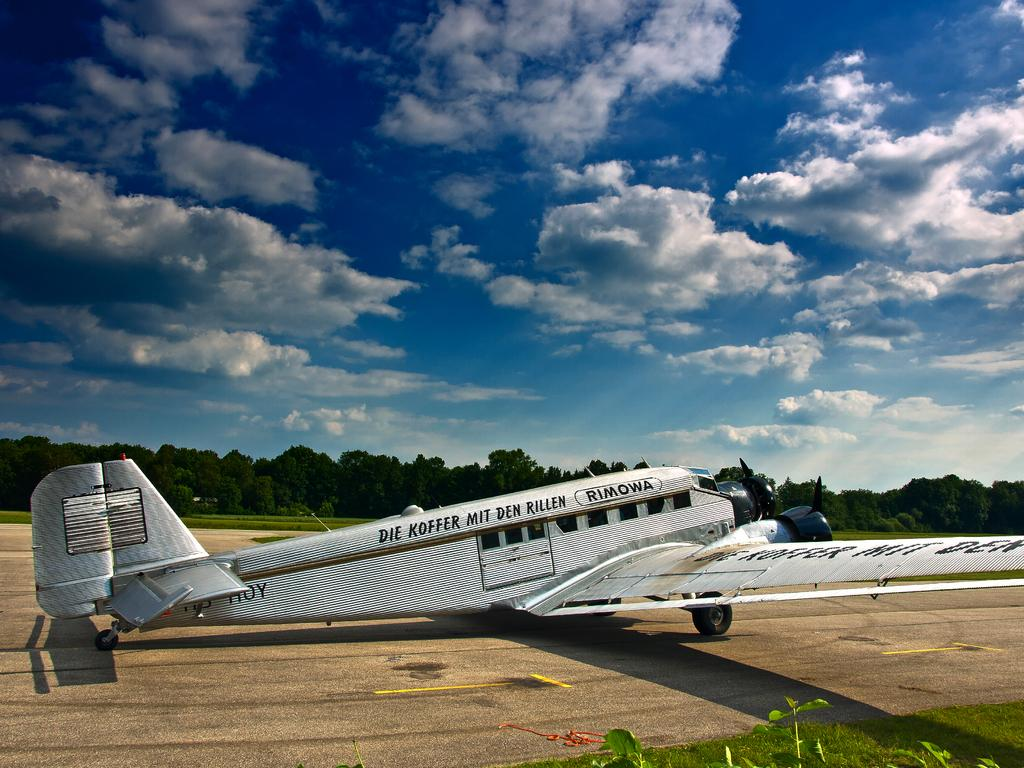<image>
Offer a succinct explanation of the picture presented. an old plane reading Die Koffer Mit Den Rillen sits on a runway 